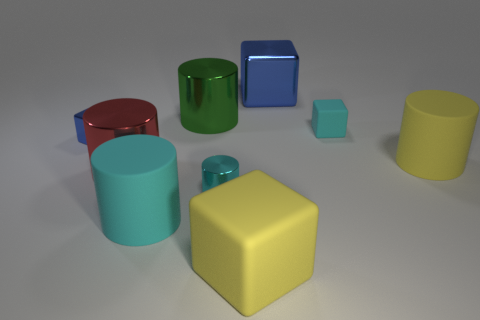There is another cube that is the same color as the large metallic block; what material is it?
Your response must be concise. Metal. There is a shiny thing that is the same color as the small rubber cube; what is its size?
Your response must be concise. Small. Does the small shiny cylinder have the same color as the tiny rubber thing?
Your answer should be very brief. Yes. Is there any other thing of the same color as the small matte cube?
Keep it short and to the point. Yes. What is the cylinder that is on the right side of the cyan rubber object that is on the right side of the tiny cyan object that is in front of the tiny matte block made of?
Your response must be concise. Rubber. How many cyan things have the same size as the green shiny object?
Your answer should be very brief. 1. What is the material of the big thing that is both on the left side of the cyan metal cylinder and behind the red cylinder?
Your response must be concise. Metal. How many large red cylinders are on the right side of the tiny cyan shiny object?
Your answer should be compact. 0. Do the large cyan rubber thing and the small metallic object that is to the right of the green object have the same shape?
Your answer should be very brief. Yes. Are there any other cyan objects of the same shape as the big cyan rubber thing?
Provide a short and direct response. Yes. 